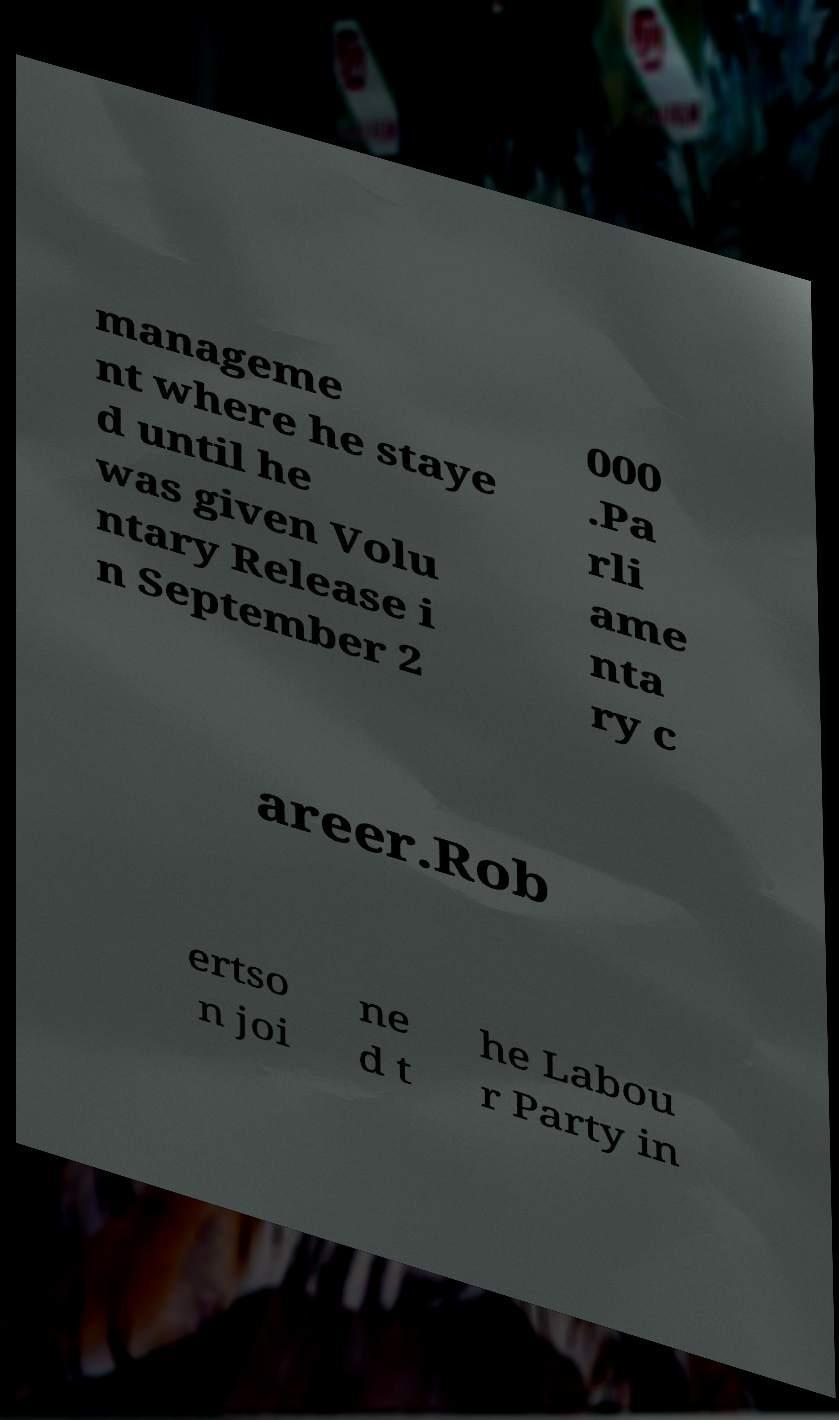Please read and relay the text visible in this image. What does it say? manageme nt where he staye d until he was given Volu ntary Release i n September 2 000 .Pa rli ame nta ry c areer.Rob ertso n joi ne d t he Labou r Party in 